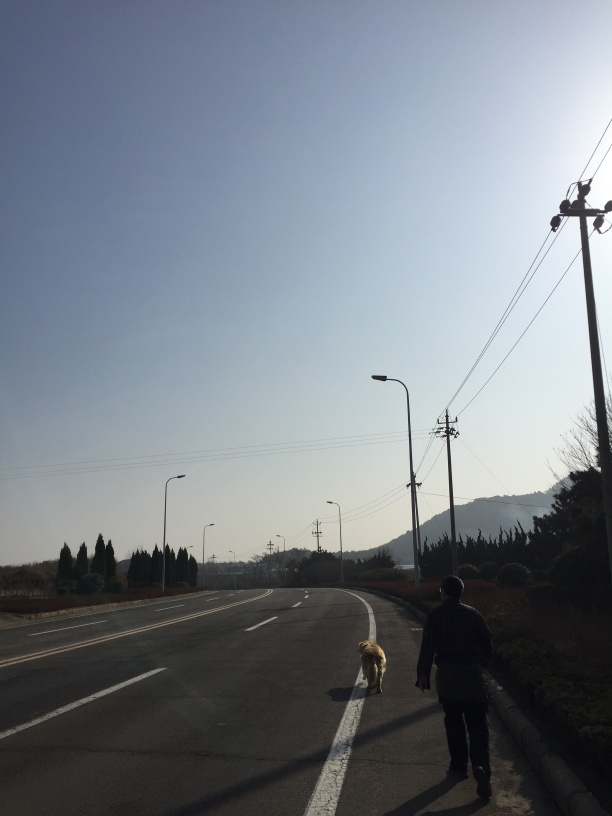Can you tell what season it might be from this image? It's hard to determine the exact season with certainty, but the absence of leaves on some of the trees and the attire of the person suggests it could be late autumn or winter. 